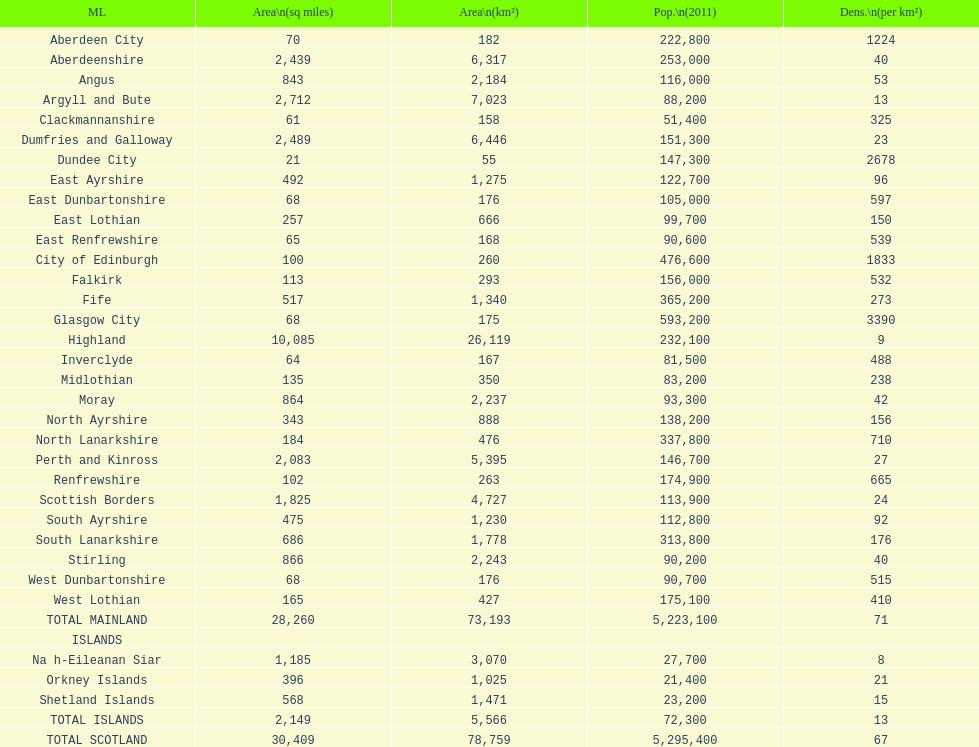What is the number of people living in angus in 2011? 116,000. 